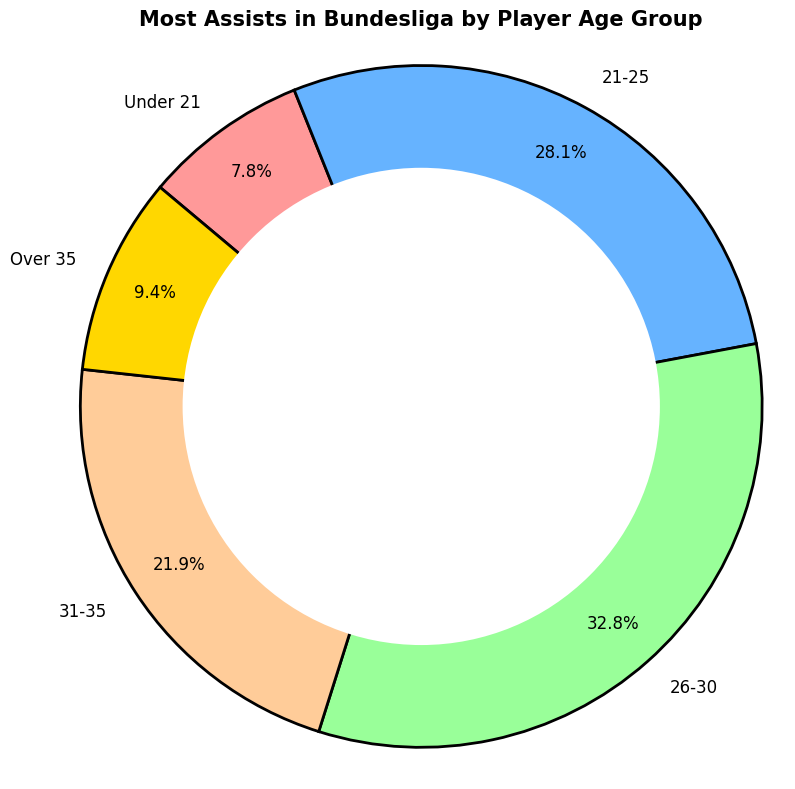Which age group has the highest number of assists? By looking at the ring chart, identify the age group segment that represents the largest portion. This segment will indicate the age group with the highest number of assists.
Answer: 26-30 What percentage of total assists are made by players aged 21-25? Locate the segment for the 21-25 age group in the ring chart and check the percentage labeled.
Answer: 32.1% How many more assists do players aged 26-30 have compared to those aged over 35? From the chart, note the assists for the 26-30 age group (630) and the Over 35 age group (180). Compute the difference: 630 - 180.
Answer: 450 Which two age groups contribute to more than 50% of all assists combined? Identify the percentages for each age group and sum up combinations to find which two exceed 50%. The sum of the percentages for 26-30 (37.5%) and 21-25 (32.1%) exceeds 50%.
Answer: 26-30 and 21-25 Which age group has the least number of assists? Identify the smallest portion in the ring chart, which corresponds to the group with the least assists.
Answer: Under 21 Calculate the combined percentage of assists made by players aged under 21 and those aged over 35. Determine the percentages for the Under 21 and Over 35 segments (8.9% and 10.7% respectively) and sum them up: 8.9% + 10.7%.
Answer: 19.6% Are the assists by players aged 31-35 closer in number to those by players aged 21-25 or under 21? Compare the assist numbers for 31-35 (420), 21-25 (540), and Under 21 (150). Assess the difference:
Answer: Under 21 What is the difference in the percentage of assists made by players aged 31-35 and those over 35? Check the percentages for 31-35 (25.0%) and Over 35 (10.7%). Calculate the difference: 25.0% - 10.7%.
Answer: 14.3% If you sum the assists made by players aged under 21 and those 21-25, how does this total compare to the assists by players aged 26-30? Combine the assists for Under 21 (150) and 21-25 (540) to get 690. Compare this with the assists for 26-30 (630). 690 > 630.
Answer: Greater than 